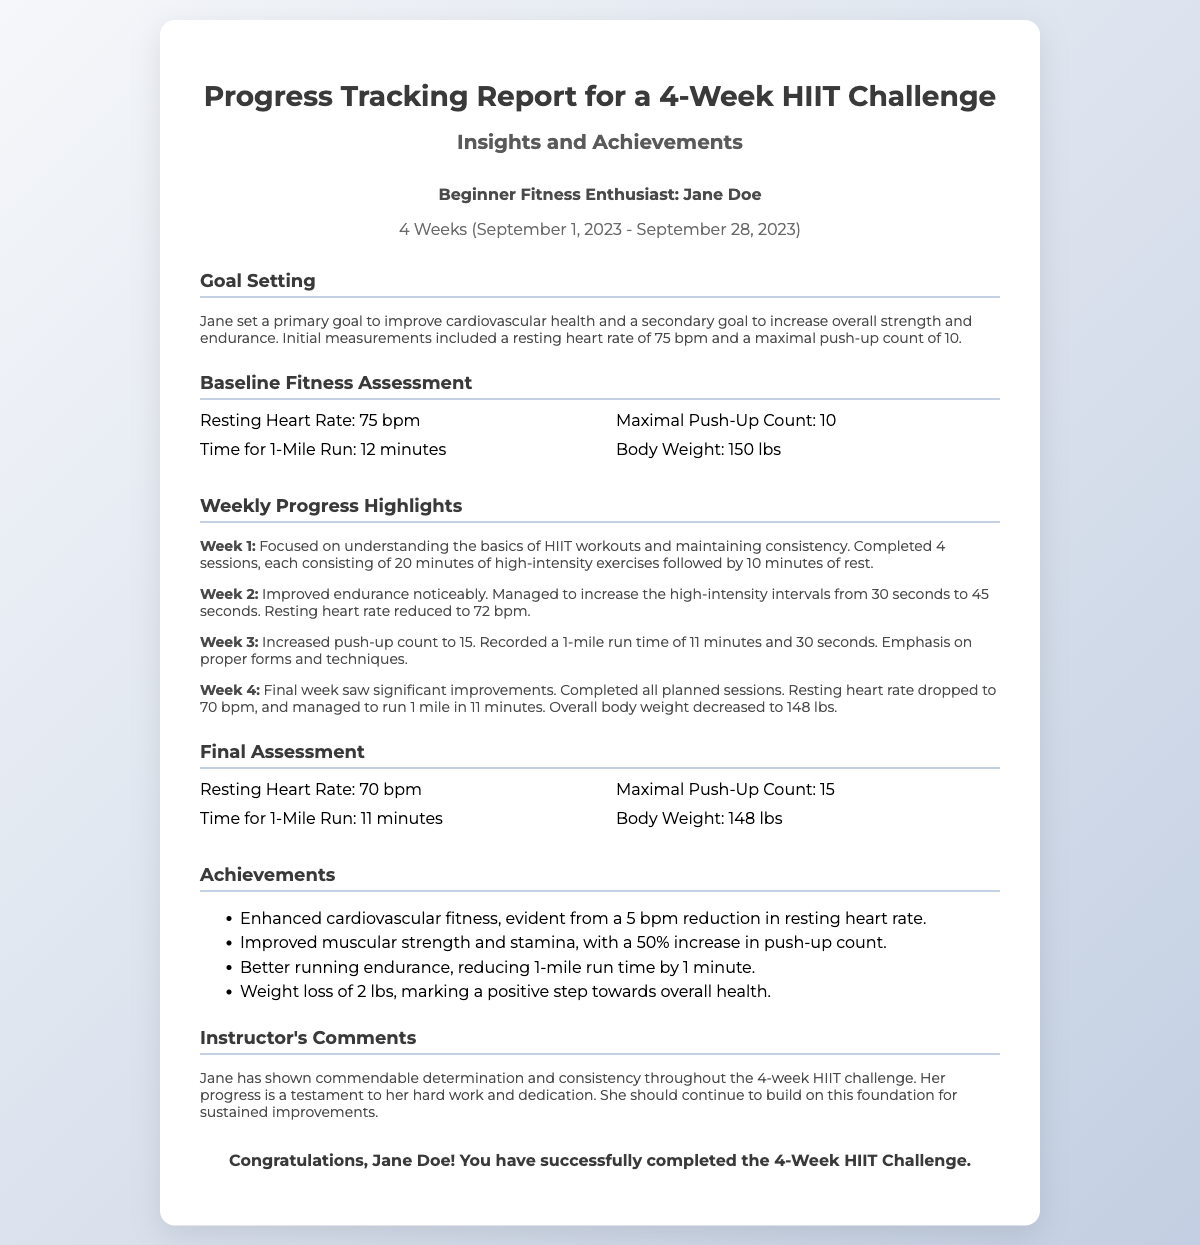What were Jane's primary fitness goals? Jane's primary goal was to improve cardiovascular health and her secondary goal was to increase overall strength and endurance.
Answer: Improve cardiovascular health and increase overall strength and endurance What was Jane's resting heart rate at the beginning of the challenge? The initial measurement of her resting heart rate was 75 bpm.
Answer: 75 bpm How many push-ups could Jane do at the end of the 4 weeks? By the end of the challenge, Jane's maximal push-up count increased to 15.
Answer: 15 What was Jane's body weight change during the challenge? Jane's body weight decreased from 150 lbs to 148 lbs over the course of the challenge.
Answer: Decreased to 148 lbs What specific improvement did Jane achieve in her 1-mile run time? Jane improved her 1-mile run time from 12 minutes to 11 minutes by the end of the challenge.
Answer: Reduced by 1 minute What did the instructor note about Jane's overall attitude during the challenge? The instructor commented on Jane's commendable determination and consistency throughout the challenge.
Answer: Commendable determination and consistency In which week did Jane increase her high-intensity intervals from 30 seconds to 45 seconds? This improvement took place in Week 2 of the challenge.
Answer: Week 2 What is the duration of the HIIT challenge? The HIIT challenge lasted 4 weeks, from September 1, 2023, to September 28, 2023.
Answer: 4 Weeks (September 1, 2023 - September 28, 2023) 